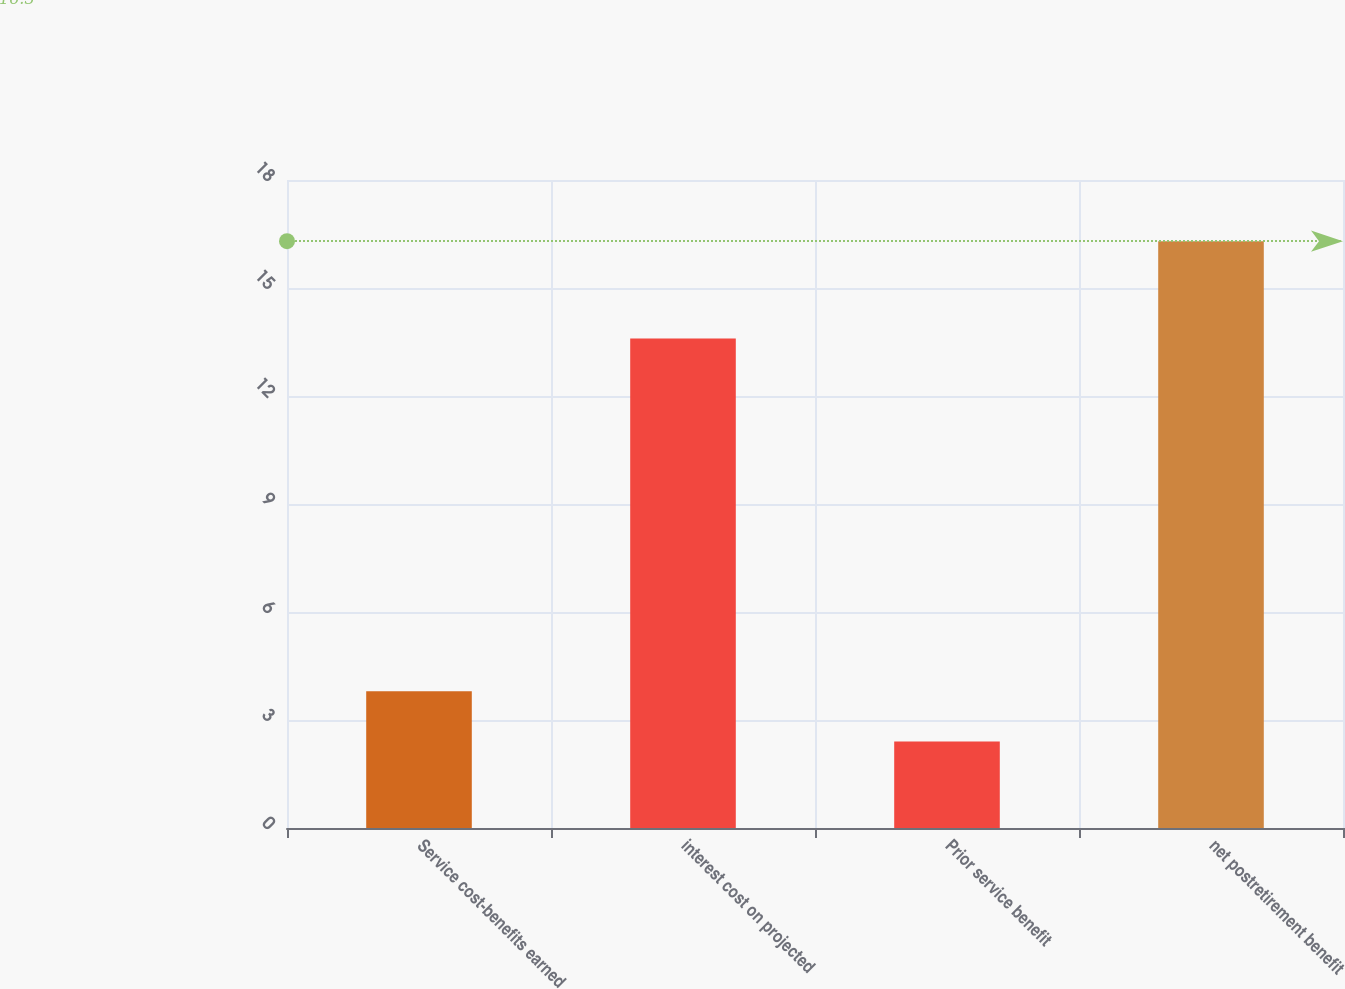Convert chart to OTSL. <chart><loc_0><loc_0><loc_500><loc_500><bar_chart><fcel>Service cost-benefits earned<fcel>interest cost on projected<fcel>Prior service benefit<fcel>net postretirement benefit<nl><fcel>3.8<fcel>13.6<fcel>2.4<fcel>16.3<nl></chart> 